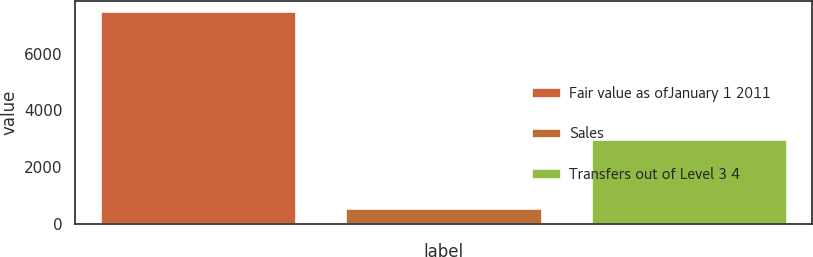Convert chart. <chart><loc_0><loc_0><loc_500><loc_500><bar_chart><fcel>Fair value as ofJanuary 1 2011<fcel>Sales<fcel>Transfers out of Level 3 4<nl><fcel>7489<fcel>580<fcel>2990<nl></chart> 